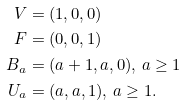<formula> <loc_0><loc_0><loc_500><loc_500>V & = ( 1 , 0 , 0 ) \\ F & = ( 0 , 0 , 1 ) \\ B _ { a } & = ( a + 1 , a , 0 ) , \, a \geq 1 \\ U _ { a } & = ( a , a , 1 ) , \, a \geq 1 .</formula> 